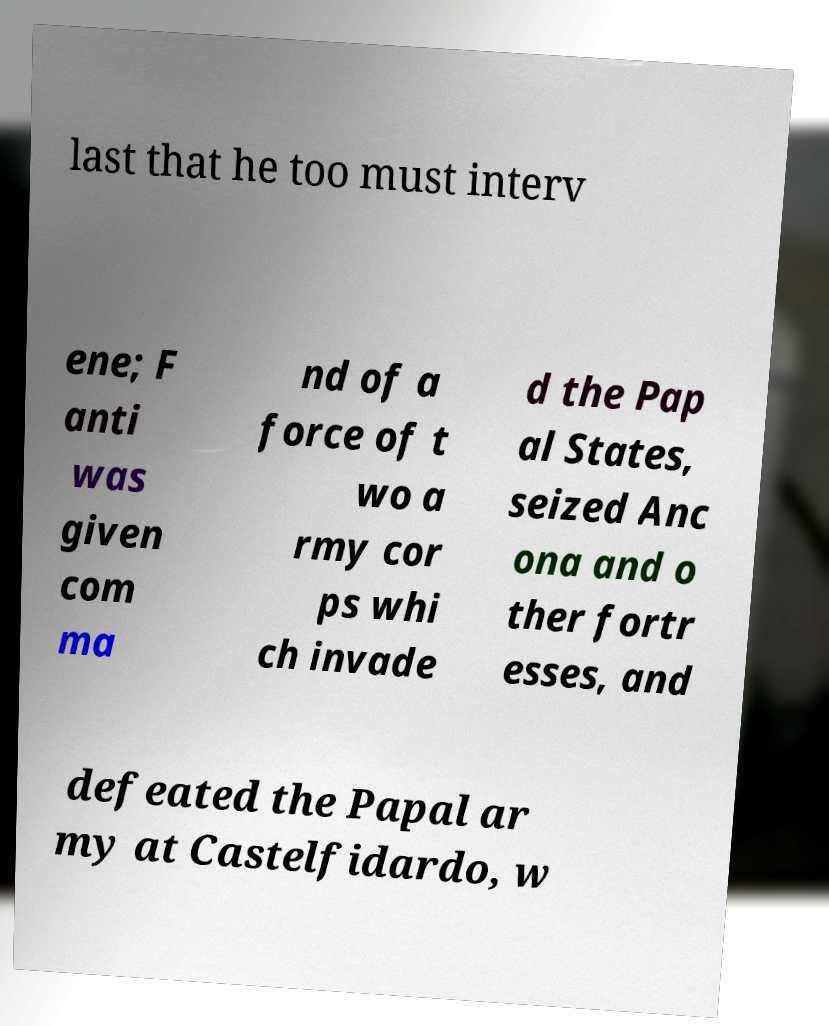For documentation purposes, I need the text within this image transcribed. Could you provide that? last that he too must interv ene; F anti was given com ma nd of a force of t wo a rmy cor ps whi ch invade d the Pap al States, seized Anc ona and o ther fortr esses, and defeated the Papal ar my at Castelfidardo, w 